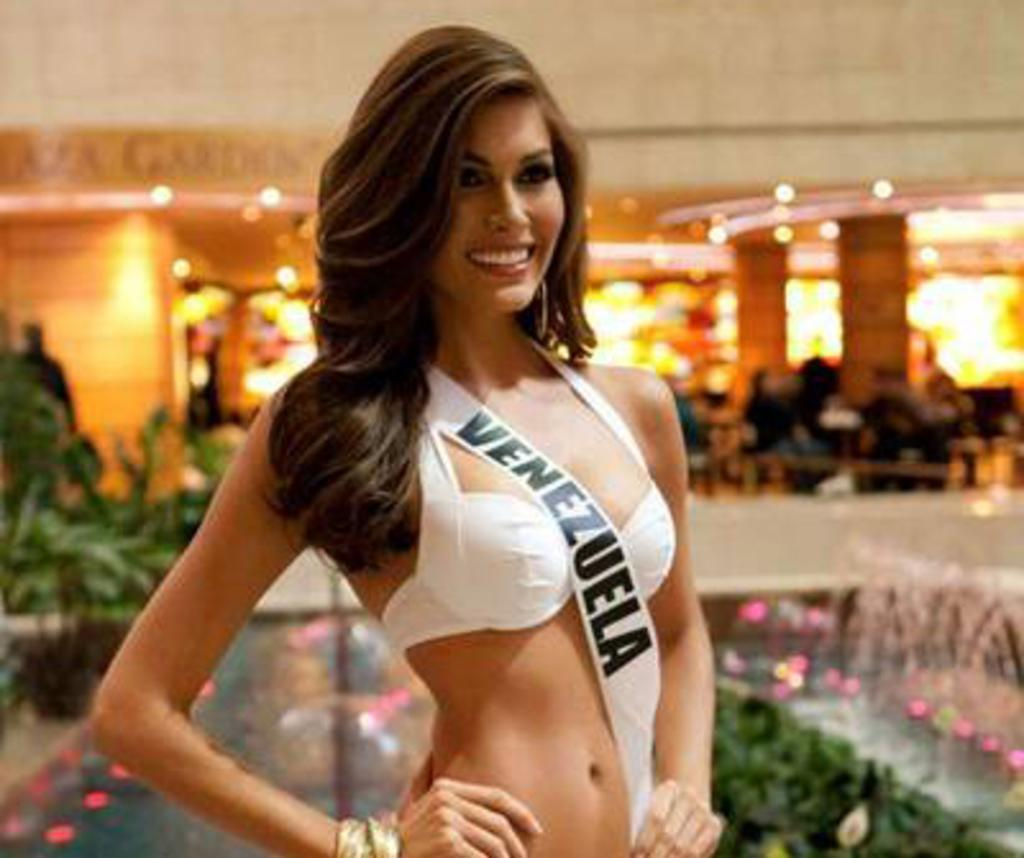Who is present in the image? There is a woman in the image. What is the woman wearing? The woman is wearing a white dress. What is the woman's facial expression? The woman is smiling. What can be seen on the left side of the image? There are plants on the left side of the image. How would you describe the background of the image? The background of the image is blurred. What type of cup is the woman holding in the image? There is no cup present in the image; the woman is not holding anything. 